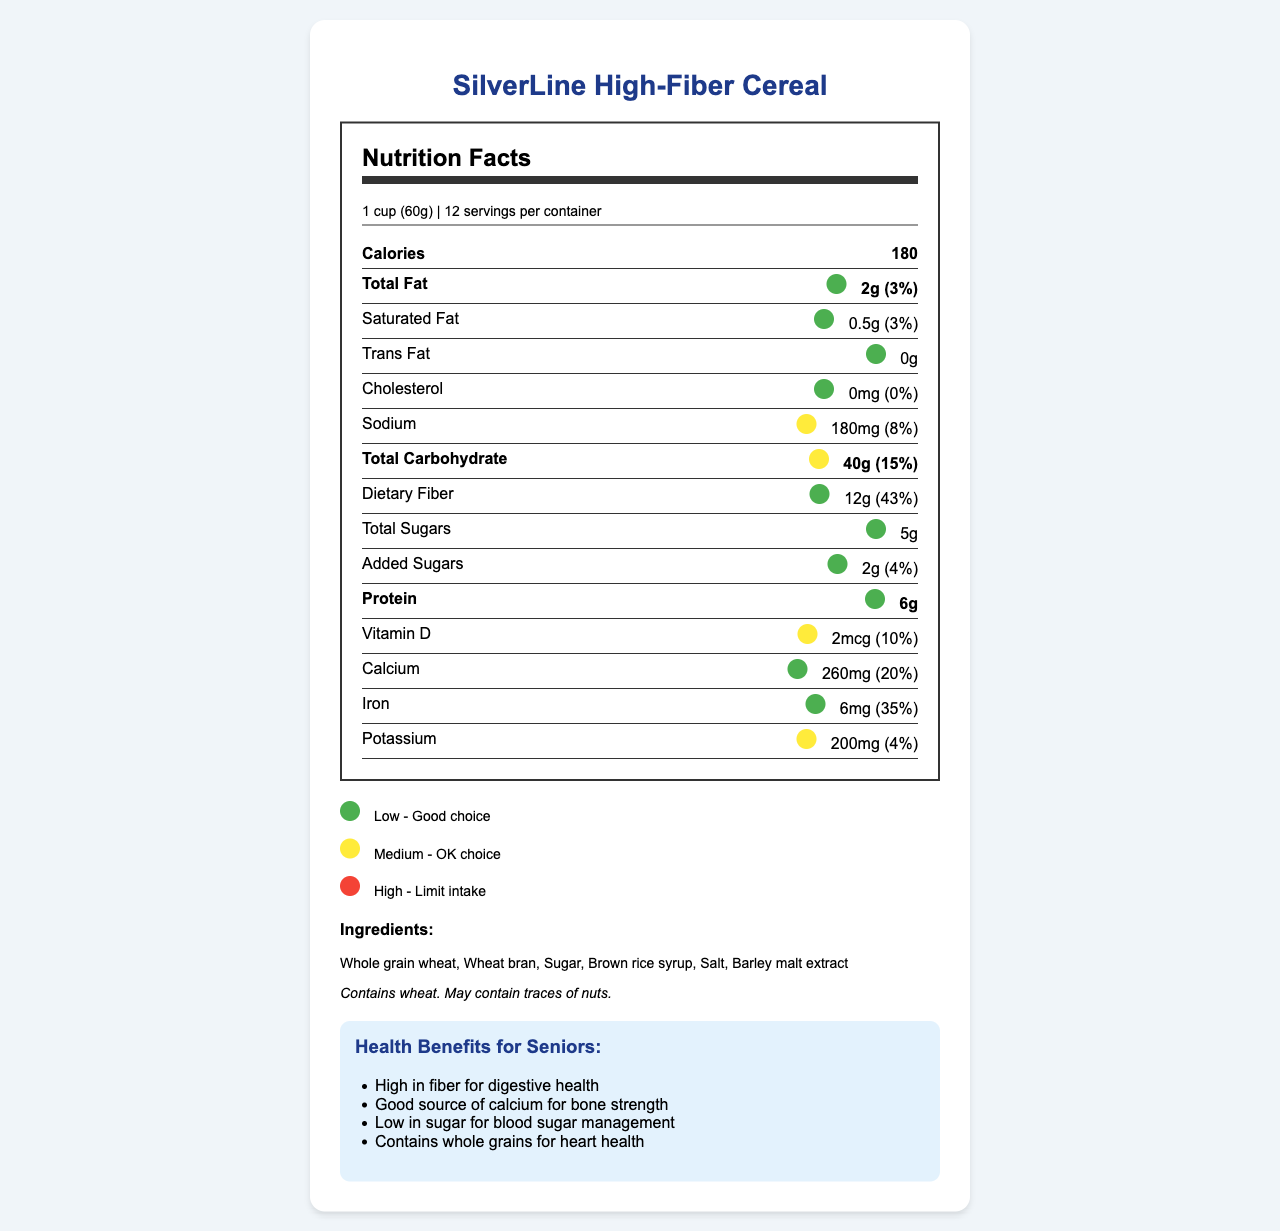what is the serving size? The serving size is specified at the beginning of the nutrition facts section as "1 cup (60g)".
Answer: 1 cup (60g) how many servings are in the container? The number of servings per container is listed right after the serving size as "12 servings per container".
Answer: 12 what is the total fat per serving? Under the section for Total Fat, it states the amount is "2g".
Answer: 2g what percentage of the daily value is the dietary fiber per serving? Under the section for Dietary Fiber, it states the percent daily value is "43%".
Answer: 43% how much calcium is in one serving and what percentage of the daily value is it? Under the section for Calcium, it lists the amount as "260mg" and the percent daily value as "20%".
Answer: 260mg, 20% what color is associated with low levels of nutrients? A. Red B. Yellow C. Green According to the color legend, green indicates "Low - Good choice".
Answer: C which nutrient has the highest yellow indicator? A. Sodium B. Total Carbohydrate C. Potassium Total Carbohydrate has a yellow indicator with 40g and a daily value of 15%, which is higher than the daily value for sodium (8%) and potassium (4%).
Answer: B does this cereal contain nuts? The allergen information states: "Contains wheat. May contain traces of nuts."
Answer: May contain traces of nuts is the amount of saturated fat considered a low, medium, or high level? The color indicator for Saturated Fat is green, which corresponds to "Low - Good choice" in the legend.
Answer: Low level summarize the main health benefits of SilverLine High-Fiber Cereal for seniors. The benefits section highlights these points specifically as benefits for seniors.
Answer: High in fiber for digestive health, good source of calcium for bone strength, low in sugar for blood sugar management, contains whole grains for heart health what main idea does this document convey? The document details the nutrition content per serving, color codes for nutrient levels, ingredient list, allergen warnings, and senior-specific health benefits while emphasizing ease of reading and understanding.
Answer: The document provides nutrition facts, ingredients, allergen information, and health benefits of SilverLine High-Fiber Cereal with a focus on visual clarity and senior-friendly features. how much added sugar does one serving contain? The added sugars section specifies the amount as "2g".
Answer: 2g what smartphone app feature allows you to get nutrition info by scanning? One of the smartphone app features listed is "Scan barcode for instant nutrition info".
Answer: Scan barcode for instant nutrition info can this cereal help with bone strength? One of the senior-friendly benefits mentioned is "Good source of calcium for bone strength".
Answer: Yes what are the benefits of high fiber in the diet according to the document? The senior-friendly benefits section states that high fiber is good for digestive health.
Answer: Digestive health what is the cost of one container of this cereal? The document does not provide any information about the price or cost of the cereal.
Answer: Cannot be determined 